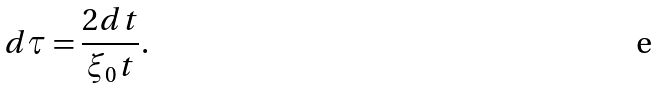Convert formula to latex. <formula><loc_0><loc_0><loc_500><loc_500>d \tau = \frac { 2 d t } { \xi _ { 0 } t } .</formula> 